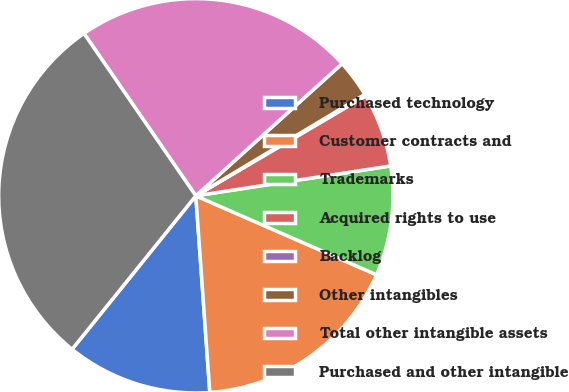<chart> <loc_0><loc_0><loc_500><loc_500><pie_chart><fcel>Purchased technology<fcel>Customer contracts and<fcel>Trademarks<fcel>Acquired rights to use<fcel>Backlog<fcel>Other intangibles<fcel>Total other intangible assets<fcel>Purchased and other intangible<nl><fcel>11.93%<fcel>17.31%<fcel>8.98%<fcel>6.04%<fcel>0.14%<fcel>3.09%<fcel>22.91%<fcel>29.6%<nl></chart> 